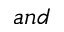Convert formula to latex. <formula><loc_0><loc_0><loc_500><loc_500>a n d</formula> 